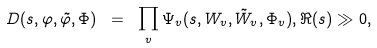Convert formula to latex. <formula><loc_0><loc_0><loc_500><loc_500>D ( s , \varphi , \tilde { \varphi } , \Phi ) \ = \ \prod _ { v } \Psi _ { v } ( s , W _ { v } , \tilde { W } _ { v } , \Phi _ { v } ) , \Re ( s ) \gg 0 ,</formula> 